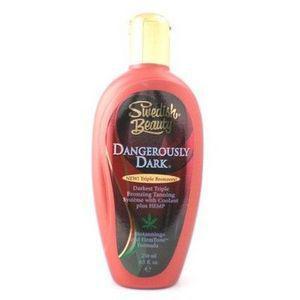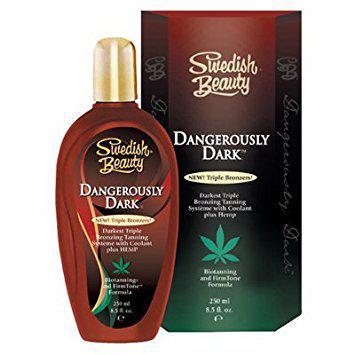The first image is the image on the left, the second image is the image on the right. Examine the images to the left and right. Is the description "One image shows a bottle standing alone, with its lid at the top, and the other image shows a bottle in front of and overlapping its upright box." accurate? Answer yes or no. Yes. The first image is the image on the left, the second image is the image on the right. Examine the images to the left and right. Is the description "At least one of the images shows the product next to the packaging." accurate? Answer yes or no. Yes. 